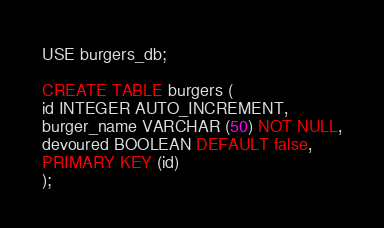<code> <loc_0><loc_0><loc_500><loc_500><_SQL_>USE burgers_db;

CREATE TABLE burgers (
id INTEGER AUTO_INCREMENT,
burger_name VARCHAR (50) NOT NULL,
devoured BOOLEAN DEFAULT false,
PRIMARY KEY (id) 
);
</code> 